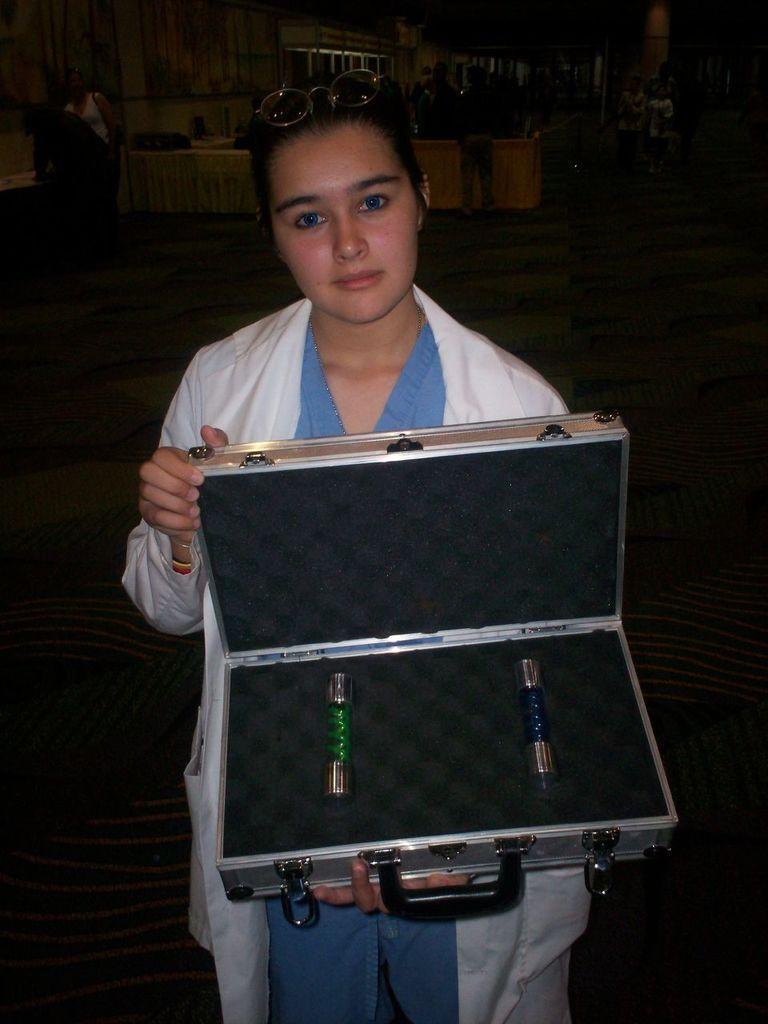How would you summarize this image in a sentence or two? The woman in white jacket is holding a box with 2 bottles. Far there are other persons standing and we can able to see tables. 